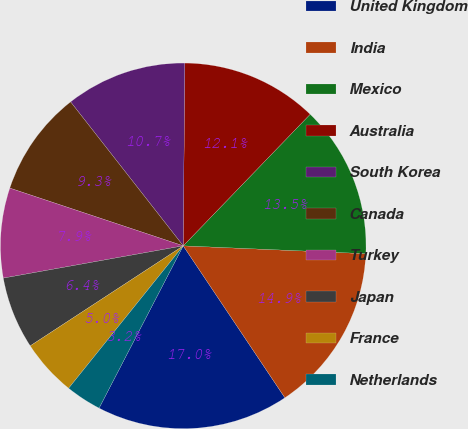Convert chart. <chart><loc_0><loc_0><loc_500><loc_500><pie_chart><fcel>United Kingdom<fcel>India<fcel>Mexico<fcel>Australia<fcel>South Korea<fcel>Canada<fcel>Turkey<fcel>Japan<fcel>France<fcel>Netherlands<nl><fcel>17.0%<fcel>14.93%<fcel>13.47%<fcel>12.08%<fcel>10.7%<fcel>9.32%<fcel>7.94%<fcel>6.39%<fcel>5.0%<fcel>3.17%<nl></chart> 